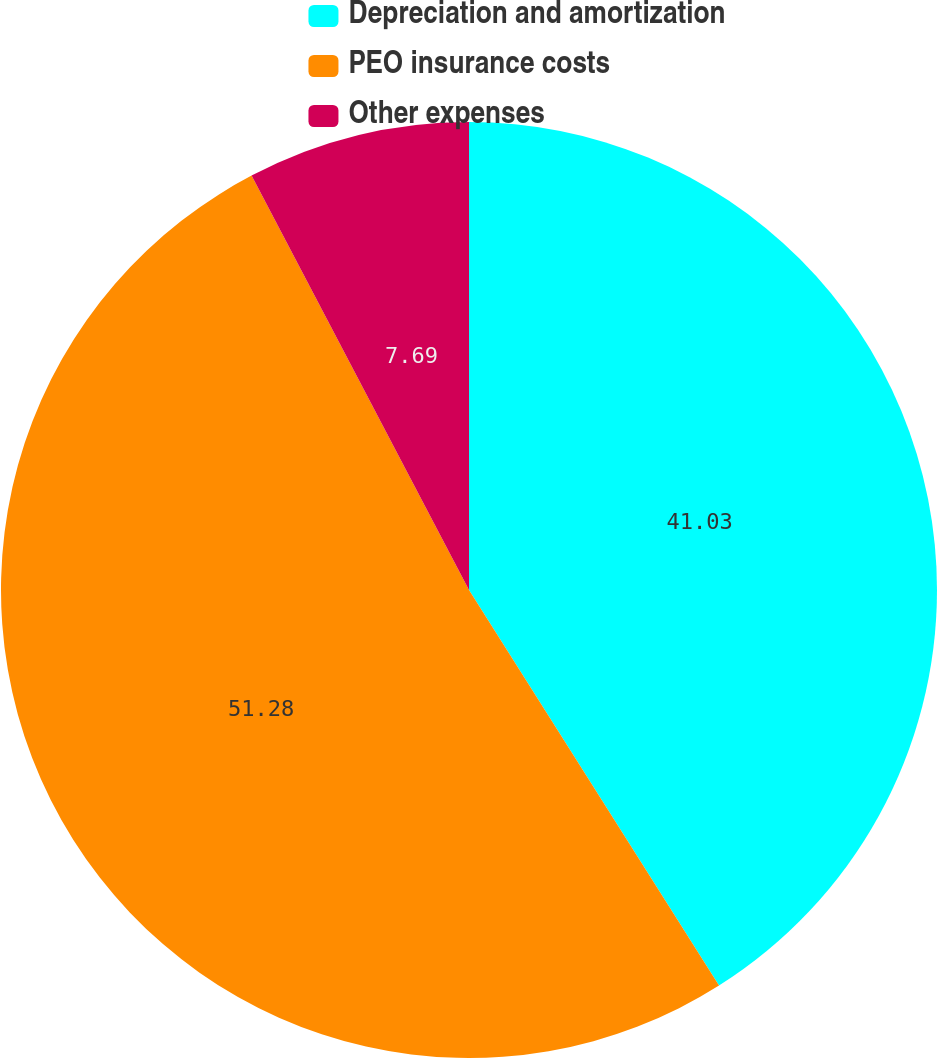Convert chart. <chart><loc_0><loc_0><loc_500><loc_500><pie_chart><fcel>Depreciation and amortization<fcel>PEO insurance costs<fcel>Other expenses<nl><fcel>41.03%<fcel>51.28%<fcel>7.69%<nl></chart> 